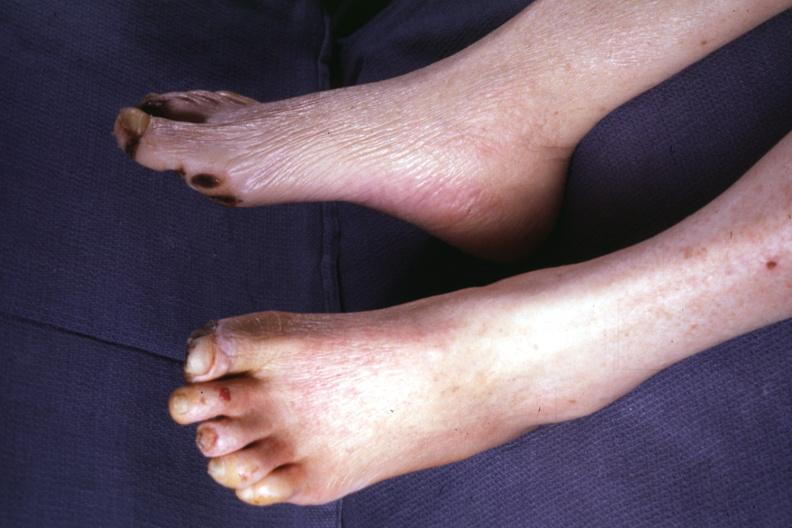what does this image show?
Answer the question using a single word or phrase. Typical gangrene 